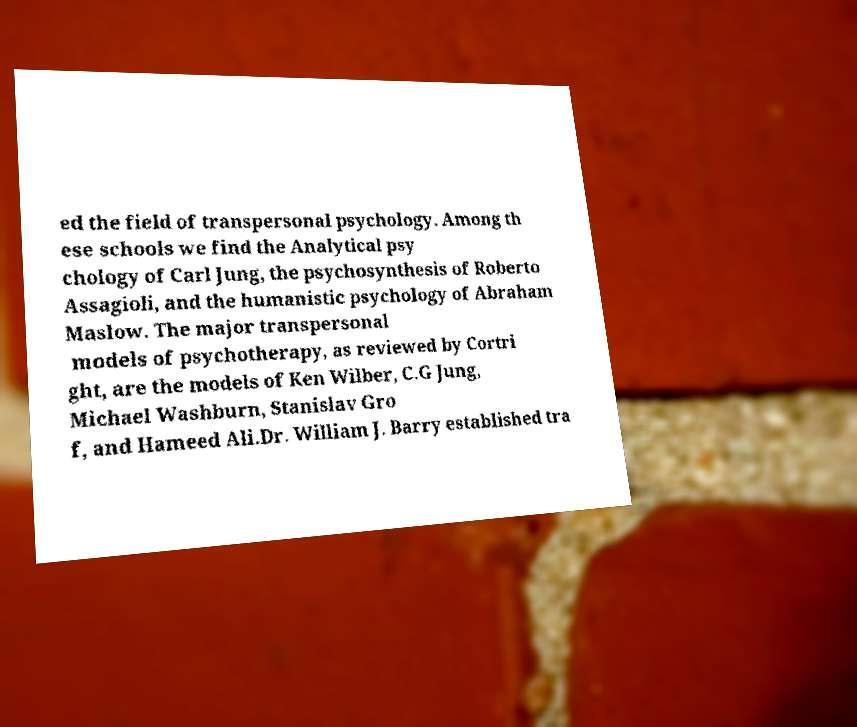Please read and relay the text visible in this image. What does it say? ed the field of transpersonal psychology. Among th ese schools we find the Analytical psy chology of Carl Jung, the psychosynthesis of Roberto Assagioli, and the humanistic psychology of Abraham Maslow. The major transpersonal models of psychotherapy, as reviewed by Cortri ght, are the models of Ken Wilber, C.G Jung, Michael Washburn, Stanislav Gro f, and Hameed Ali.Dr. William J. Barry established tra 